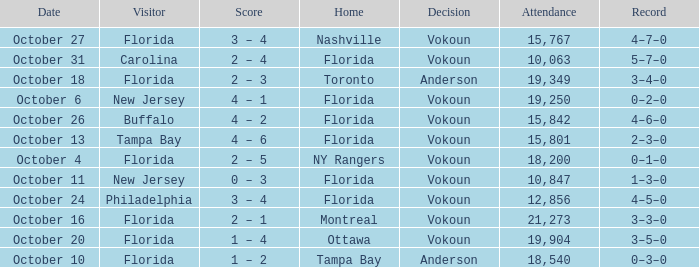Which team won when the visitor was Carolina? Vokoun. 